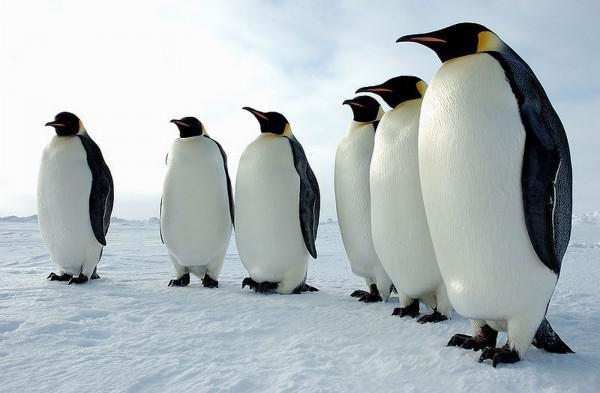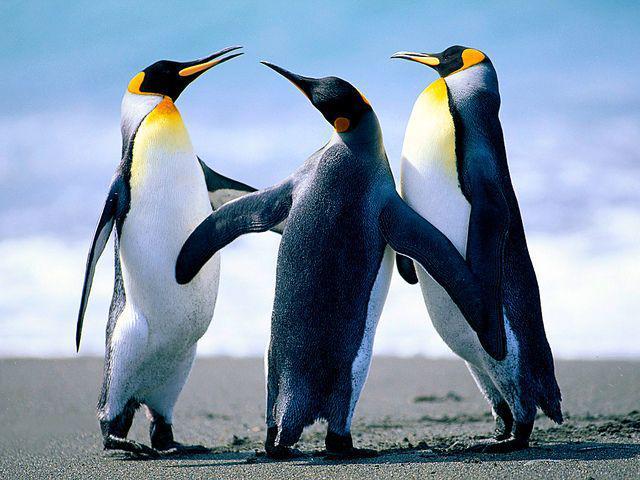The first image is the image on the left, the second image is the image on the right. Assess this claim about the two images: "An image shows exactly two penguins who appear to be walking """"hand-in-hand"""".". Correct or not? Answer yes or no. No. The first image is the image on the left, the second image is the image on the right. For the images shown, is this caption "There are two penguins in the right image." true? Answer yes or no. No. 